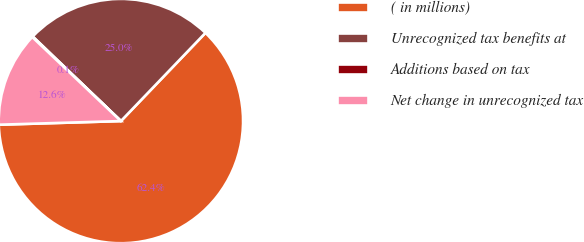Convert chart to OTSL. <chart><loc_0><loc_0><loc_500><loc_500><pie_chart><fcel>( in millions)<fcel>Unrecognized tax benefits at<fcel>Additions based on tax<fcel>Net change in unrecognized tax<nl><fcel>62.36%<fcel>25.0%<fcel>0.09%<fcel>12.55%<nl></chart> 